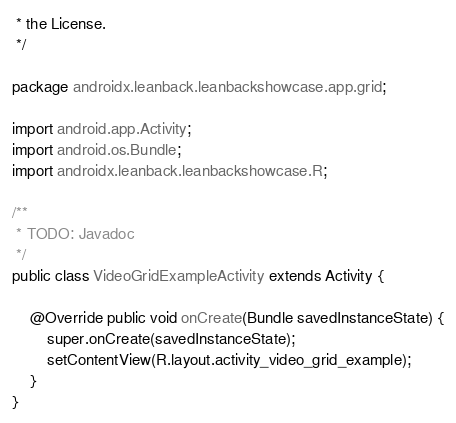Convert code to text. <code><loc_0><loc_0><loc_500><loc_500><_Java_> * the License.
 */

package androidx.leanback.leanbackshowcase.app.grid;

import android.app.Activity;
import android.os.Bundle;
import androidx.leanback.leanbackshowcase.R;

/**
 * TODO: Javadoc
 */
public class VideoGridExampleActivity extends Activity {

    @Override public void onCreate(Bundle savedInstanceState) {
        super.onCreate(savedInstanceState);
        setContentView(R.layout.activity_video_grid_example);
    }
}
</code> 